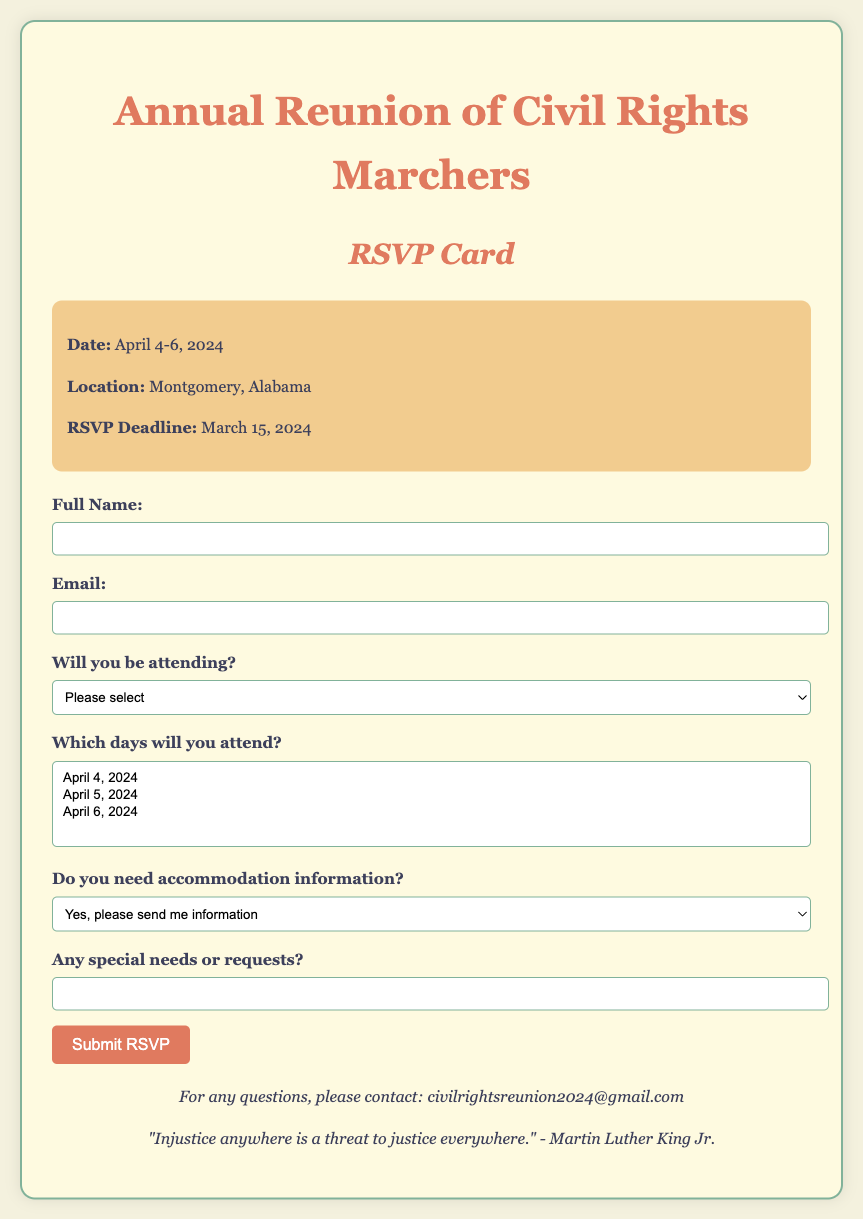what is the date of the reunion? The date of the reunion is explicitly mentioned in the document.
Answer: April 4-6, 2024 where is the reunion taking place? The location of the reunion is provided clearly in the document.
Answer: Montgomery, Alabama when is the RSVP deadline? The document specifies the cutoff date for RSVPs.
Answer: March 15, 2024 what option do I select if I will attend? The document outlines options for attendance in the RSVP section.
Answer: Yes, I will attend how many days can I select for attendance? The document allows selections for multiple days for attendance.
Answer: Multiple what email should I contact for questions? The document includes a contact email for inquiries.
Answer: civilrightsreunion2024@gmail.com what statement is included from Martin Luther King Jr.? The document features a quote from Martin Luther King Jr. to encourage participation.
Answer: "Injustice anywhere is a threat to justice everywhere." what does the accommodation option ask? The document provides a specific question regarding accommodation needs in the RSVP.
Answer: Do you need accommodation information? 